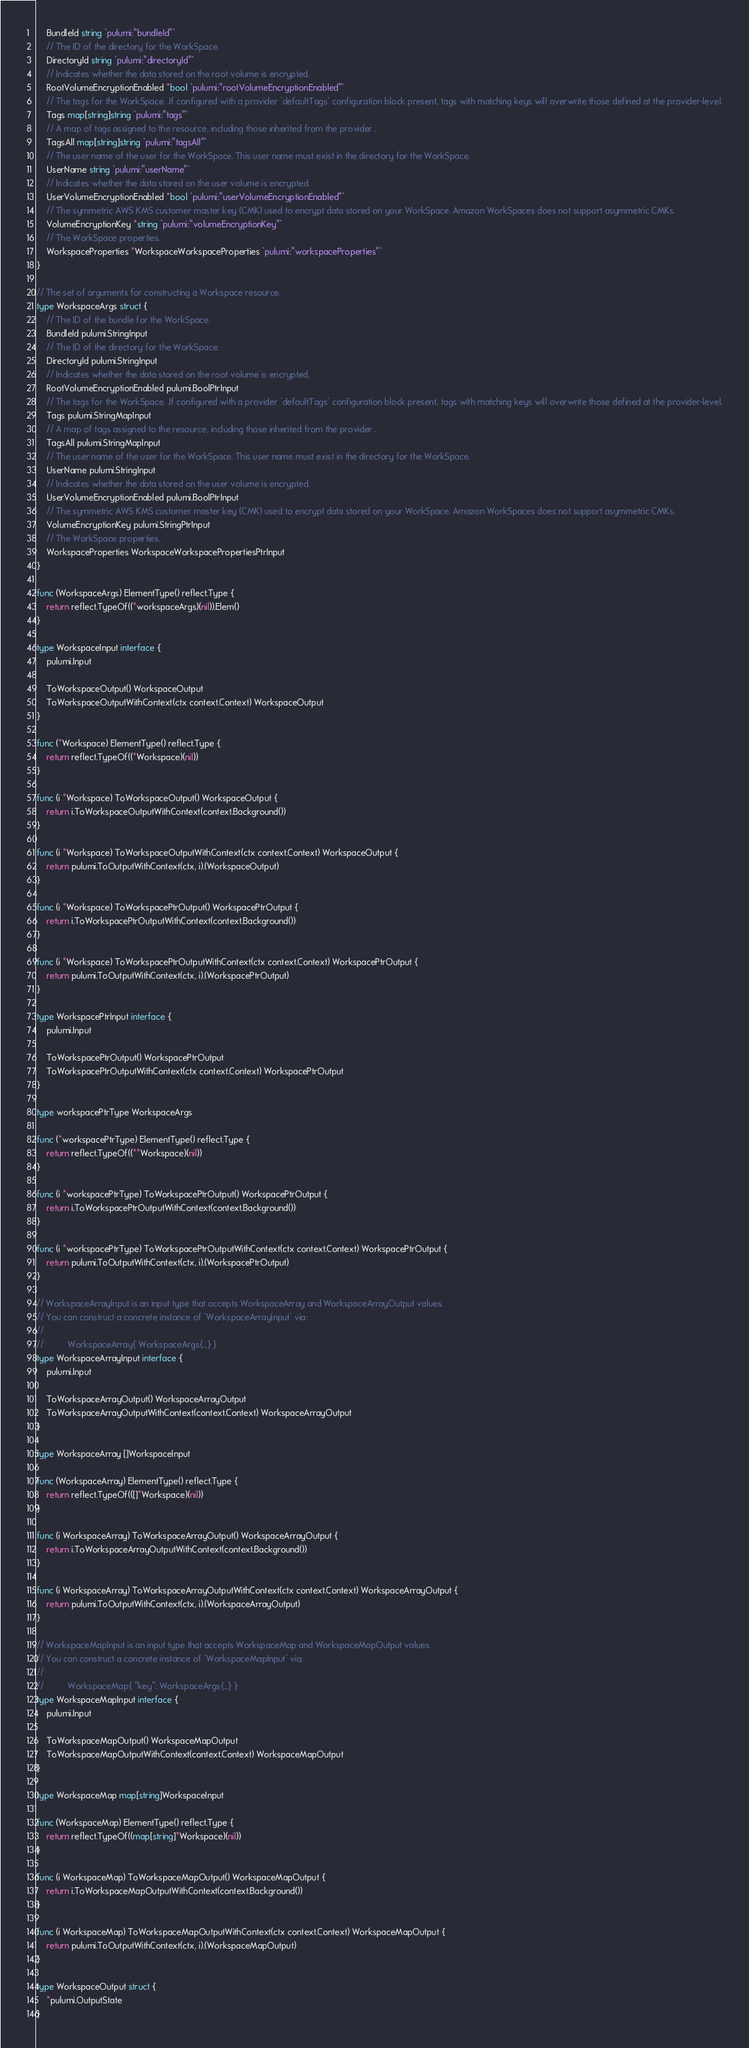Convert code to text. <code><loc_0><loc_0><loc_500><loc_500><_Go_>	BundleId string `pulumi:"bundleId"`
	// The ID of the directory for the WorkSpace.
	DirectoryId string `pulumi:"directoryId"`
	// Indicates whether the data stored on the root volume is encrypted.
	RootVolumeEncryptionEnabled *bool `pulumi:"rootVolumeEncryptionEnabled"`
	// The tags for the WorkSpace. .If configured with a provider `defaultTags` configuration block present, tags with matching keys will overwrite those defined at the provider-level.
	Tags map[string]string `pulumi:"tags"`
	// A map of tags assigned to the resource, including those inherited from the provider .
	TagsAll map[string]string `pulumi:"tagsAll"`
	// The user name of the user for the WorkSpace. This user name must exist in the directory for the WorkSpace.
	UserName string `pulumi:"userName"`
	// Indicates whether the data stored on the user volume is encrypted.
	UserVolumeEncryptionEnabled *bool `pulumi:"userVolumeEncryptionEnabled"`
	// The symmetric AWS KMS customer master key (CMK) used to encrypt data stored on your WorkSpace. Amazon WorkSpaces does not support asymmetric CMKs.
	VolumeEncryptionKey *string `pulumi:"volumeEncryptionKey"`
	// The WorkSpace properties.
	WorkspaceProperties *WorkspaceWorkspaceProperties `pulumi:"workspaceProperties"`
}

// The set of arguments for constructing a Workspace resource.
type WorkspaceArgs struct {
	// The ID of the bundle for the WorkSpace.
	BundleId pulumi.StringInput
	// The ID of the directory for the WorkSpace.
	DirectoryId pulumi.StringInput
	// Indicates whether the data stored on the root volume is encrypted.
	RootVolumeEncryptionEnabled pulumi.BoolPtrInput
	// The tags for the WorkSpace. .If configured with a provider `defaultTags` configuration block present, tags with matching keys will overwrite those defined at the provider-level.
	Tags pulumi.StringMapInput
	// A map of tags assigned to the resource, including those inherited from the provider .
	TagsAll pulumi.StringMapInput
	// The user name of the user for the WorkSpace. This user name must exist in the directory for the WorkSpace.
	UserName pulumi.StringInput
	// Indicates whether the data stored on the user volume is encrypted.
	UserVolumeEncryptionEnabled pulumi.BoolPtrInput
	// The symmetric AWS KMS customer master key (CMK) used to encrypt data stored on your WorkSpace. Amazon WorkSpaces does not support asymmetric CMKs.
	VolumeEncryptionKey pulumi.StringPtrInput
	// The WorkSpace properties.
	WorkspaceProperties WorkspaceWorkspacePropertiesPtrInput
}

func (WorkspaceArgs) ElementType() reflect.Type {
	return reflect.TypeOf((*workspaceArgs)(nil)).Elem()
}

type WorkspaceInput interface {
	pulumi.Input

	ToWorkspaceOutput() WorkspaceOutput
	ToWorkspaceOutputWithContext(ctx context.Context) WorkspaceOutput
}

func (*Workspace) ElementType() reflect.Type {
	return reflect.TypeOf((*Workspace)(nil))
}

func (i *Workspace) ToWorkspaceOutput() WorkspaceOutput {
	return i.ToWorkspaceOutputWithContext(context.Background())
}

func (i *Workspace) ToWorkspaceOutputWithContext(ctx context.Context) WorkspaceOutput {
	return pulumi.ToOutputWithContext(ctx, i).(WorkspaceOutput)
}

func (i *Workspace) ToWorkspacePtrOutput() WorkspacePtrOutput {
	return i.ToWorkspacePtrOutputWithContext(context.Background())
}

func (i *Workspace) ToWorkspacePtrOutputWithContext(ctx context.Context) WorkspacePtrOutput {
	return pulumi.ToOutputWithContext(ctx, i).(WorkspacePtrOutput)
}

type WorkspacePtrInput interface {
	pulumi.Input

	ToWorkspacePtrOutput() WorkspacePtrOutput
	ToWorkspacePtrOutputWithContext(ctx context.Context) WorkspacePtrOutput
}

type workspacePtrType WorkspaceArgs

func (*workspacePtrType) ElementType() reflect.Type {
	return reflect.TypeOf((**Workspace)(nil))
}

func (i *workspacePtrType) ToWorkspacePtrOutput() WorkspacePtrOutput {
	return i.ToWorkspacePtrOutputWithContext(context.Background())
}

func (i *workspacePtrType) ToWorkspacePtrOutputWithContext(ctx context.Context) WorkspacePtrOutput {
	return pulumi.ToOutputWithContext(ctx, i).(WorkspacePtrOutput)
}

// WorkspaceArrayInput is an input type that accepts WorkspaceArray and WorkspaceArrayOutput values.
// You can construct a concrete instance of `WorkspaceArrayInput` via:
//
//          WorkspaceArray{ WorkspaceArgs{...} }
type WorkspaceArrayInput interface {
	pulumi.Input

	ToWorkspaceArrayOutput() WorkspaceArrayOutput
	ToWorkspaceArrayOutputWithContext(context.Context) WorkspaceArrayOutput
}

type WorkspaceArray []WorkspaceInput

func (WorkspaceArray) ElementType() reflect.Type {
	return reflect.TypeOf(([]*Workspace)(nil))
}

func (i WorkspaceArray) ToWorkspaceArrayOutput() WorkspaceArrayOutput {
	return i.ToWorkspaceArrayOutputWithContext(context.Background())
}

func (i WorkspaceArray) ToWorkspaceArrayOutputWithContext(ctx context.Context) WorkspaceArrayOutput {
	return pulumi.ToOutputWithContext(ctx, i).(WorkspaceArrayOutput)
}

// WorkspaceMapInput is an input type that accepts WorkspaceMap and WorkspaceMapOutput values.
// You can construct a concrete instance of `WorkspaceMapInput` via:
//
//          WorkspaceMap{ "key": WorkspaceArgs{...} }
type WorkspaceMapInput interface {
	pulumi.Input

	ToWorkspaceMapOutput() WorkspaceMapOutput
	ToWorkspaceMapOutputWithContext(context.Context) WorkspaceMapOutput
}

type WorkspaceMap map[string]WorkspaceInput

func (WorkspaceMap) ElementType() reflect.Type {
	return reflect.TypeOf((map[string]*Workspace)(nil))
}

func (i WorkspaceMap) ToWorkspaceMapOutput() WorkspaceMapOutput {
	return i.ToWorkspaceMapOutputWithContext(context.Background())
}

func (i WorkspaceMap) ToWorkspaceMapOutputWithContext(ctx context.Context) WorkspaceMapOutput {
	return pulumi.ToOutputWithContext(ctx, i).(WorkspaceMapOutput)
}

type WorkspaceOutput struct {
	*pulumi.OutputState
}
</code> 